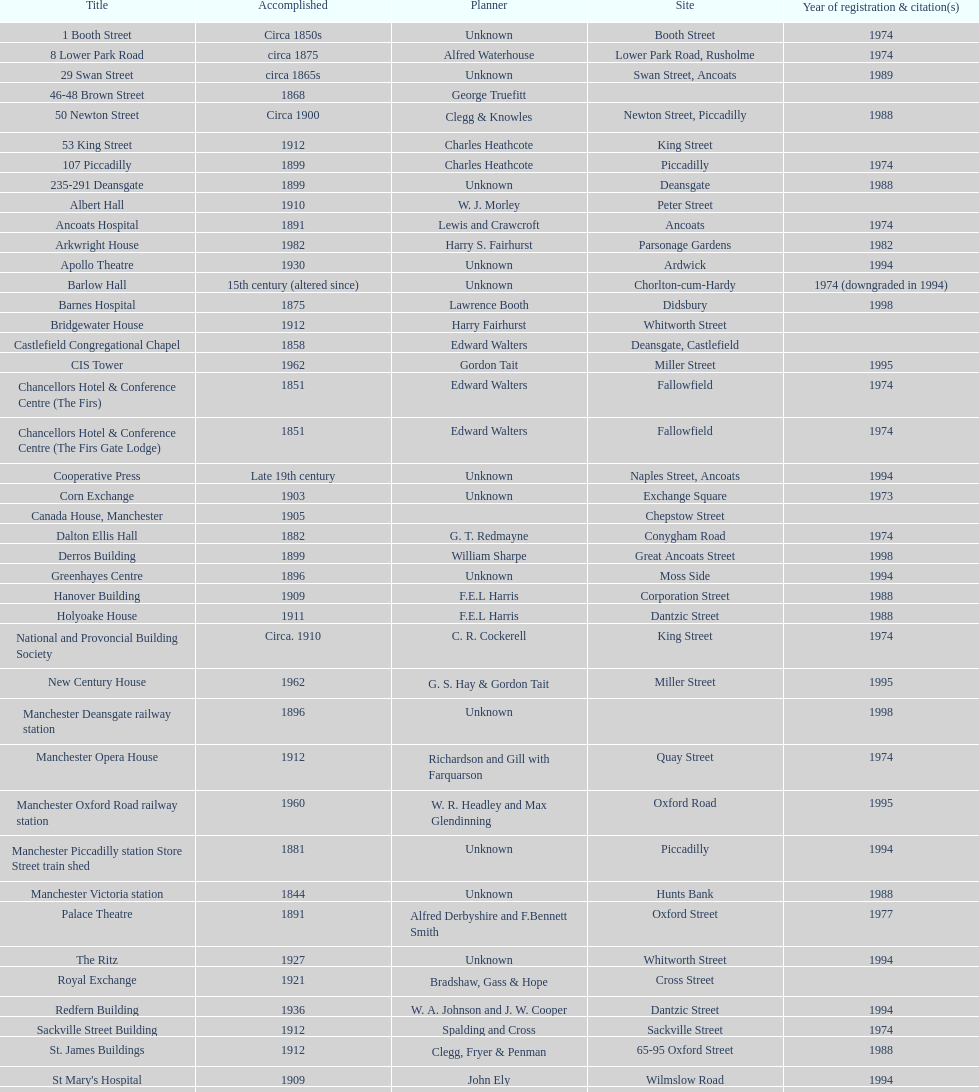How many buildings had alfred waterhouse as their architect? 3. 